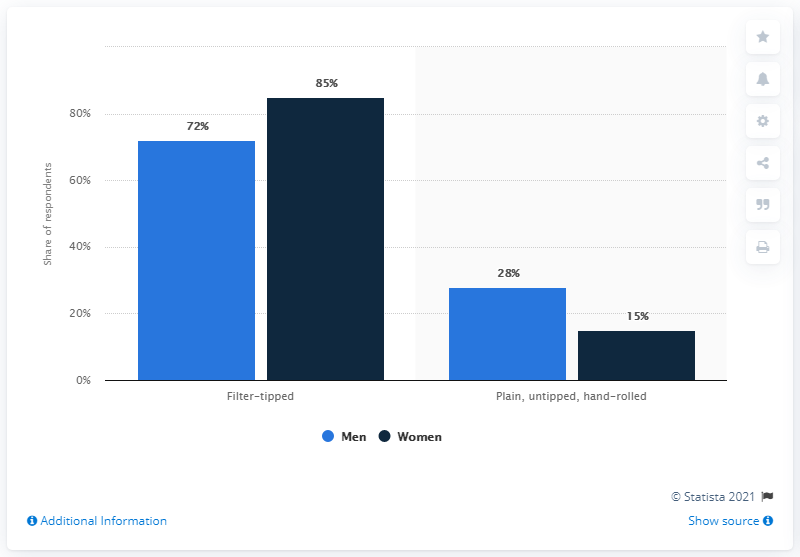List a handful of essential elements in this visual. In total, women make up [X]% of [group of women]. [group of women] refers to the specific group of women being considered. Please provide the percentage value of [X]. Women smoke the most in Filter-tipped. 